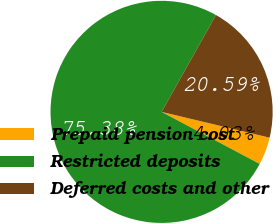Convert chart to OTSL. <chart><loc_0><loc_0><loc_500><loc_500><pie_chart><fcel>Prepaid pension cost<fcel>Restricted deposits<fcel>Deferred costs and other<nl><fcel>4.03%<fcel>75.38%<fcel>20.59%<nl></chart> 